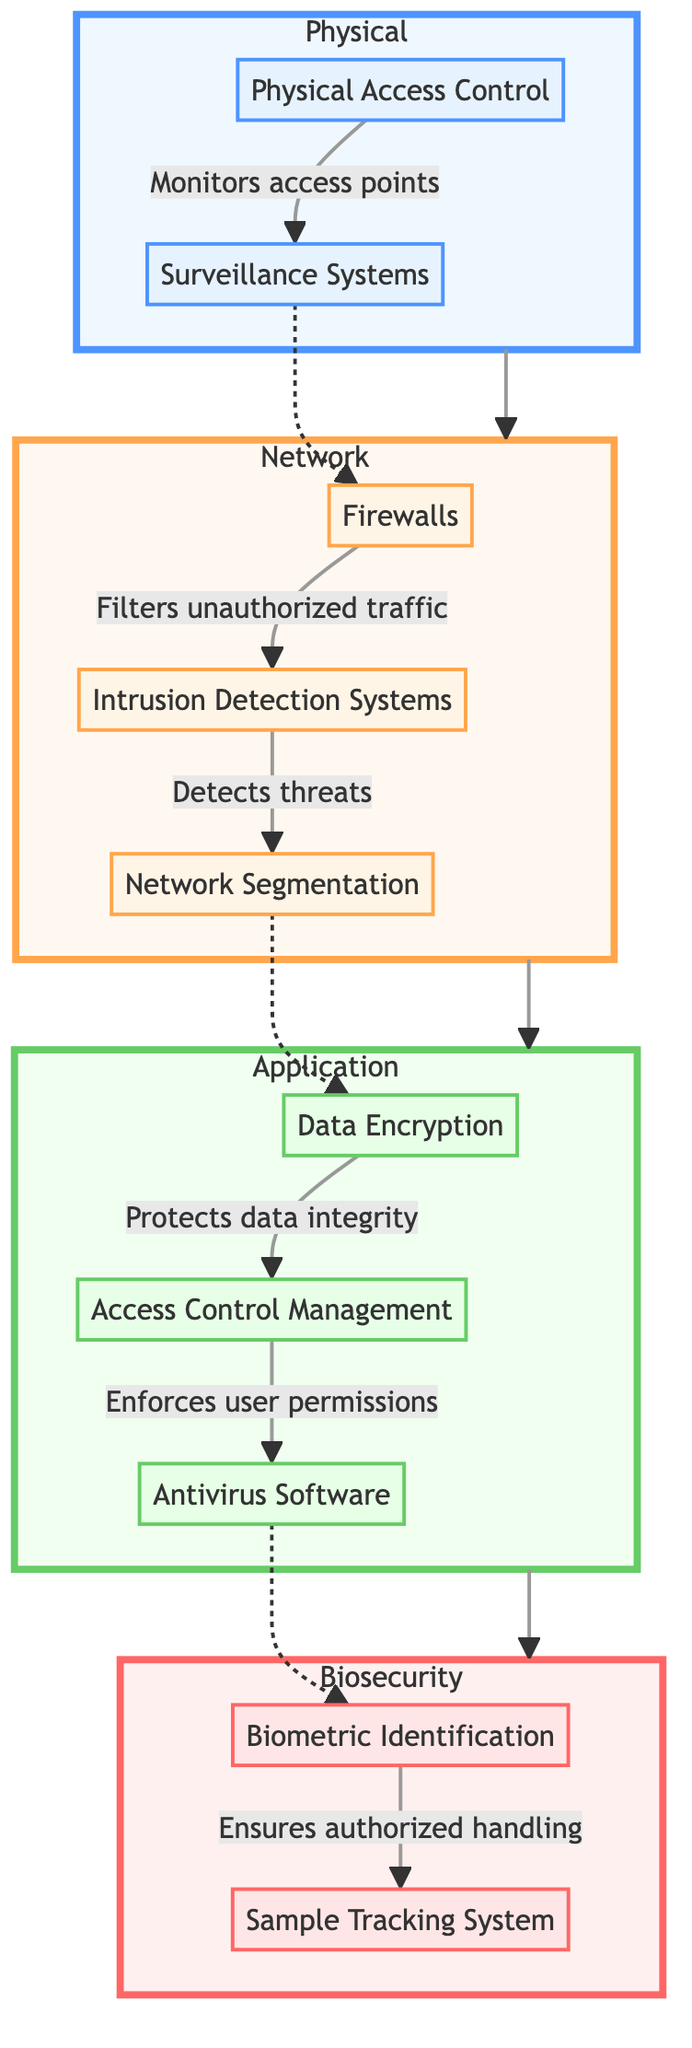What are the two components in the Physical Layer? The Physical Layer includes "Physical Access Control" and "Surveillance Systems." These are explicitly shown as nodes within the Physical subgraph.
Answer: Physical Access Control, Surveillance Systems Which component serves to filter unauthorized traffic? The component responsible for filtering unauthorized traffic is "Firewalls," connecting to the Intrusion Detection Systems in the Network Layer, as indicated by the arrow in the diagram.
Answer: Firewalls How many layers are in this diagram? The diagram contains four layers: Physical, Network, Application, and Biosecurity, which are clearly labeled and organized in a linear sequence from top to bottom.
Answer: Four What is the relationship between "Antivirus Software" and "Biometric Identification"? "Antivirus Software" is linked to "Biometric Identification" via a dashed line, indicating a connection where Antivirus Software's effectiveness impacts Biometric Identification's security.
Answer: Dashed line connection What type of access management is suggested in the Application Layer? The Application Layer suggests "Access Control Management," which is focused on managing permissions for users, as illustrated in the flow from Data Encryption.
Answer: Access Control Management Which layer has components related to data security? The Application Layer contains components related to data security, including "Data Encryption," "Access Control Management," and "Antivirus Software." This layer explicitly focuses on securing application data.
Answer: Application Layer What does "Intrusion Detection Systems" detect? "Intrusion Detection Systems" detect threats, as indicated by the directional arrow connecting it to "Network Segmentation," showing the flow of information about threat activity.
Answer: Threats How does "Sample Tracking System" ensure authorized handling? The "Sample Tracking System" ensures authorized handling through its connection with "Biometric Identification," which controls access based on identity verification.
Answer: Through Biometric Identification What is the main purpose of the Network Layer? The main purpose of the Network Layer is to secure network traffic through components like firewalls and intrusion detection, which filter and detect threats to maintain network integrity.
Answer: Secure network traffic 